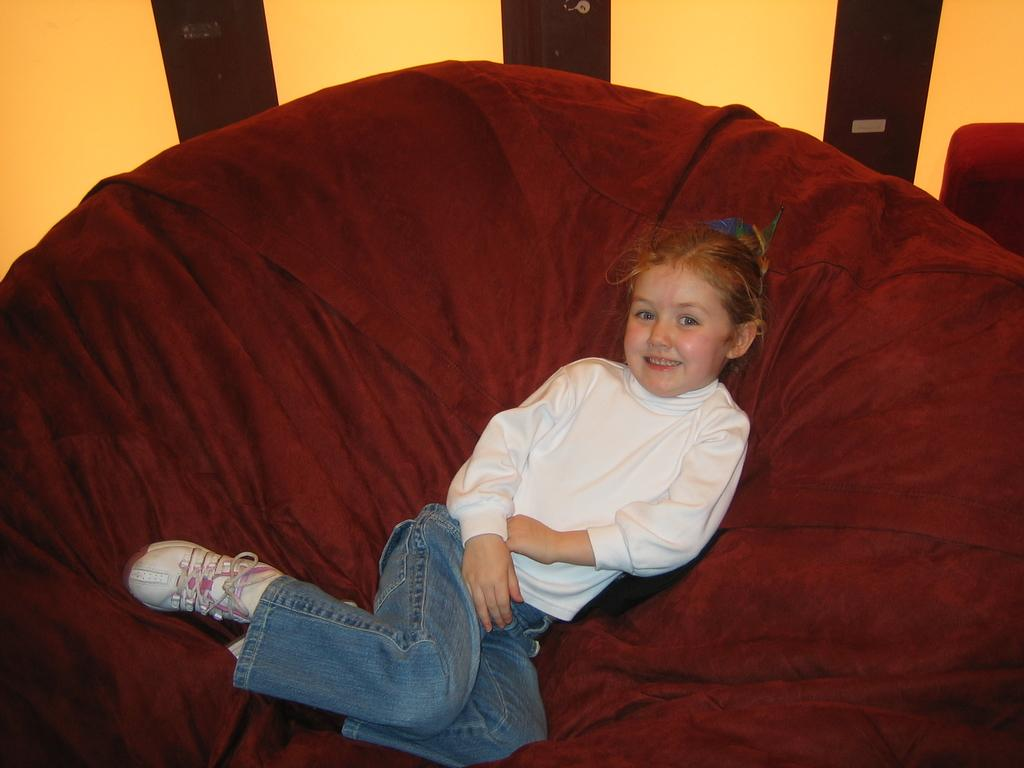Who is the main subject in the image? There is a girl in the image. What is the girl doing in the image? The girl is laying on a sofa. What can be seen in the background of the image? There is a wall in the background of the image. What type of hydrant is visible in the image? There is no hydrant present in the image. Can you tell me how many rats are sitting next to the girl in the image? There are no rats present in the image. 